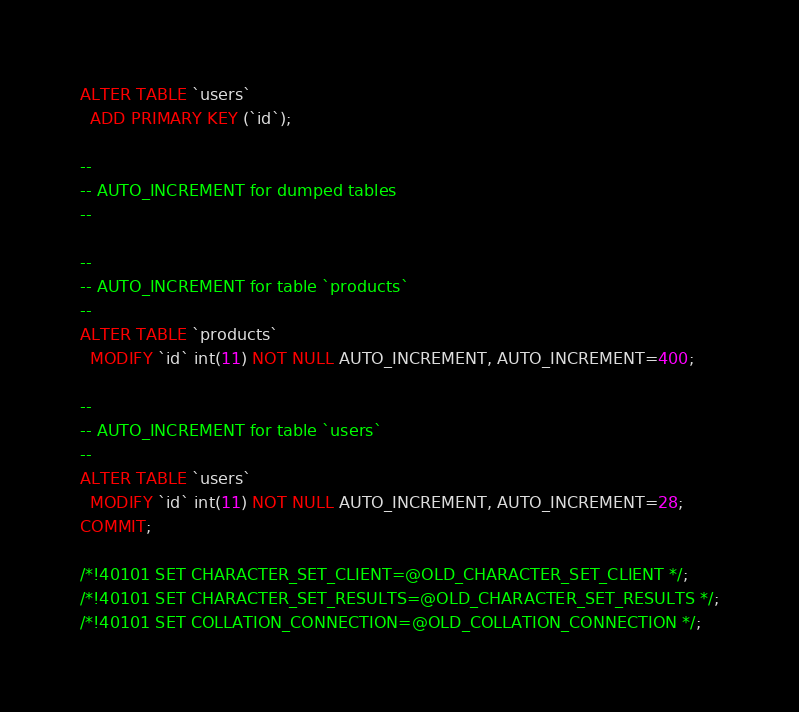Convert code to text. <code><loc_0><loc_0><loc_500><loc_500><_SQL_>ALTER TABLE `users`
  ADD PRIMARY KEY (`id`);

--
-- AUTO_INCREMENT for dumped tables
--

--
-- AUTO_INCREMENT for table `products`
--
ALTER TABLE `products`
  MODIFY `id` int(11) NOT NULL AUTO_INCREMENT, AUTO_INCREMENT=400;

--
-- AUTO_INCREMENT for table `users`
--
ALTER TABLE `users`
  MODIFY `id` int(11) NOT NULL AUTO_INCREMENT, AUTO_INCREMENT=28;
COMMIT;

/*!40101 SET CHARACTER_SET_CLIENT=@OLD_CHARACTER_SET_CLIENT */;
/*!40101 SET CHARACTER_SET_RESULTS=@OLD_CHARACTER_SET_RESULTS */;
/*!40101 SET COLLATION_CONNECTION=@OLD_COLLATION_CONNECTION */;
</code> 